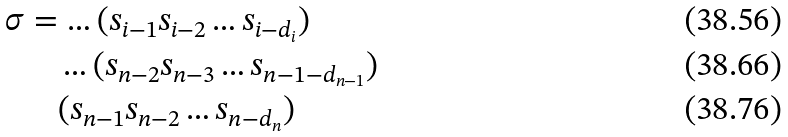Convert formula to latex. <formula><loc_0><loc_0><loc_500><loc_500>\sigma & = \hdots ( s _ { i - 1 } s _ { i - 2 } \hdots s _ { i - { d _ { i } } } ) \\ & \quad \hdots ( s _ { n - 2 } s _ { n - 3 } \hdots s _ { n - 1 - { d _ { n - 1 } } } ) \\ & \quad ( s _ { n - 1 } s _ { n - 2 } \hdots s _ { n - { d _ { n } } } )</formula> 